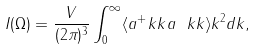Convert formula to latex. <formula><loc_0><loc_0><loc_500><loc_500>I ( \Omega ) = \frac { V } { ( 2 \pi ) ^ { 3 } } \int _ { 0 } ^ { \infty } \langle a ^ { + } _ { \ } k k a _ { \ } k k \rangle k ^ { 2 } d k ,</formula> 